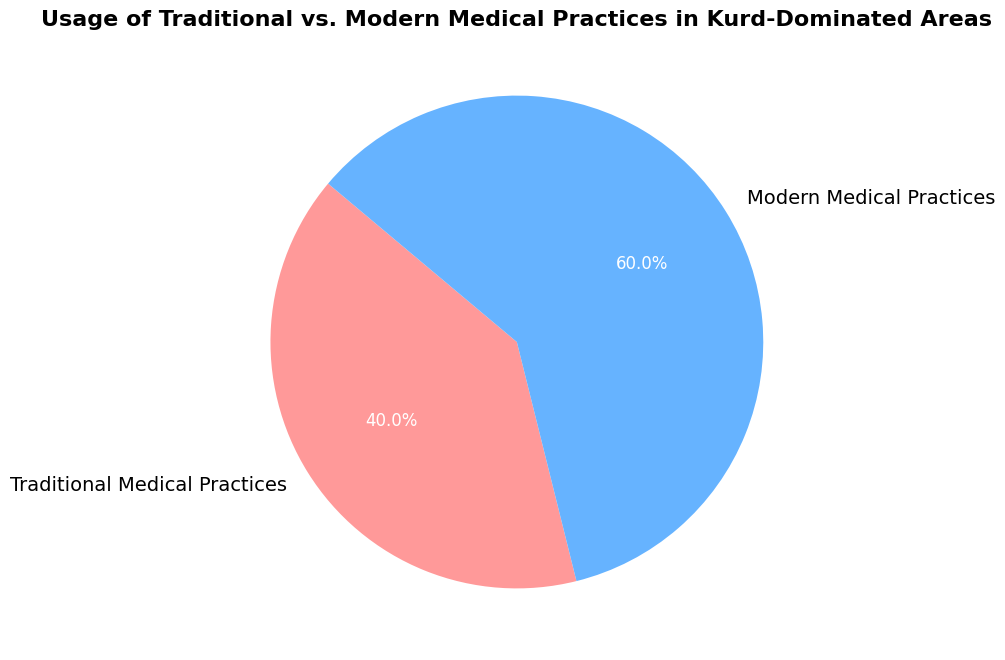What percentage of medical practices are modern in Kurd-Dominated Areas? The chart shows that Modern Medical Practices account for 60% of the total medical practices.
Answer: 60% How much more prevalent are modern medical practices compared to traditional ones? The chart shows Modern Medical Practices at 60% and Traditional Medical Practices at 40%. Subtracting these percentages gives 60% - 40% = 20%.
Answer: 20% What fraction of the total medical practices is traditional? The chart shows Traditional Medical Practices at 40%. To convert this to a fraction, 40% is equivalent to 40/100, which simplifies to 2/5.
Answer: 2/5 Are Traditional Medical Practices less than half of the total medical practices? The chart shows that Traditional Medical Practices are at 40%. Since 40% is less than 50%, the answer is yes.
Answer: Yes Which type of medical practice is more common, traditional or modern? The chart shows that Modern Medical Practices make up 60% and Traditional Medical Practices make up 40%. Since 60% is greater than 40%, Modern Medical Practices are more common.
Answer: Modern Medical Practices What is the difference in percentage between traditional and modern medical practices? According to the chart, Modern Medical Practices are 60% and Traditional are 40%. The difference is 60% - 40% = 20%.
Answer: 20% If the total number of medical consultations is 1000, how many were traditional? The chart shows that Traditional Medical Practices account for 40%. Therefore, 40% of 1000 consultations would be 0.40 * 1000 = 400.
Answer: 400 What are the two categories represented in the pie chart? The chart shows two categories: Traditional Medical Practices and Modern Medical Practices.
Answer: Traditional Medical Practices and Modern Medical Practices 